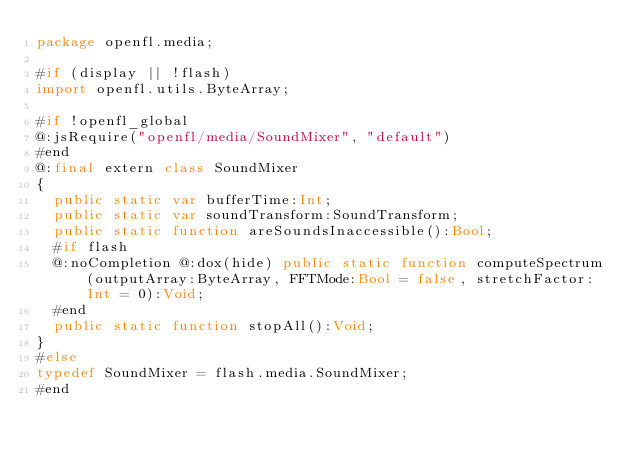<code> <loc_0><loc_0><loc_500><loc_500><_Haxe_>package openfl.media;

#if (display || !flash)
import openfl.utils.ByteArray;

#if !openfl_global
@:jsRequire("openfl/media/SoundMixer", "default")
#end
@:final extern class SoundMixer
{
	public static var bufferTime:Int;
	public static var soundTransform:SoundTransform;
	public static function areSoundsInaccessible():Bool;
	#if flash
	@:noCompletion @:dox(hide) public static function computeSpectrum(outputArray:ByteArray, FFTMode:Bool = false, stretchFactor:Int = 0):Void;
	#end
	public static function stopAll():Void;
}
#else
typedef SoundMixer = flash.media.SoundMixer;
#end
</code> 